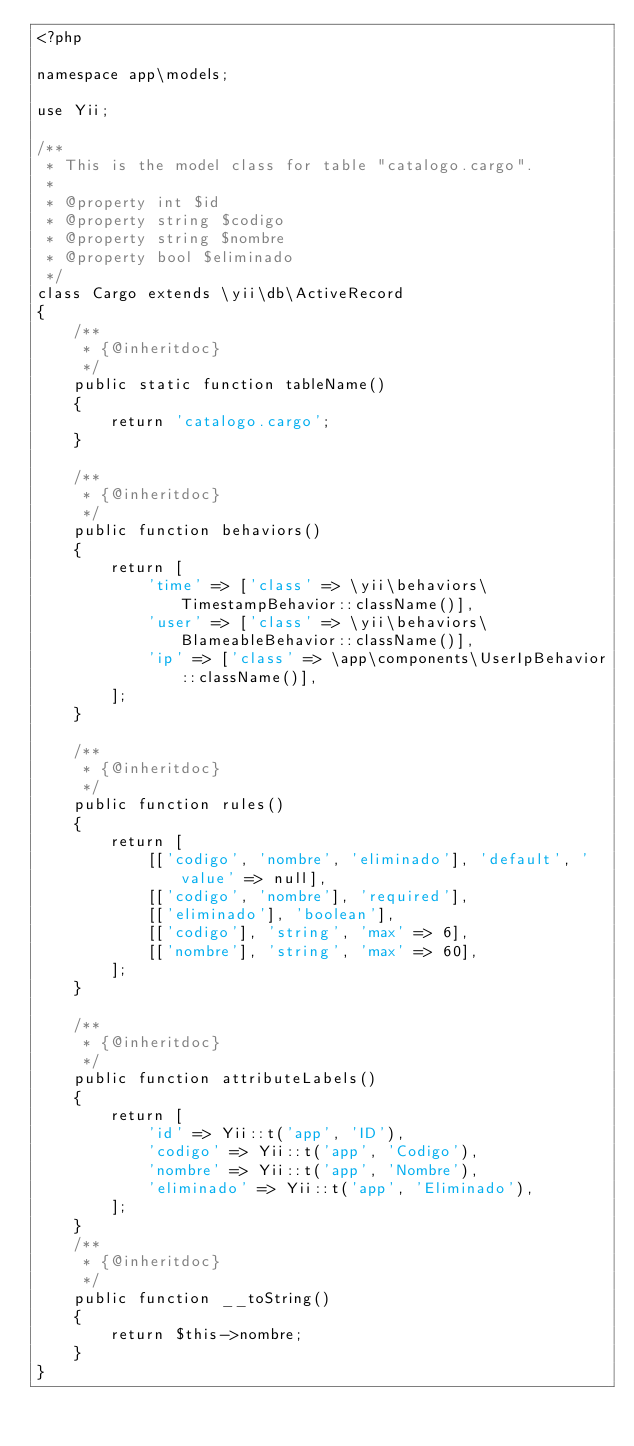Convert code to text. <code><loc_0><loc_0><loc_500><loc_500><_PHP_><?php

namespace app\models;

use Yii;

/**
 * This is the model class for table "catalogo.cargo".
 *
 * @property int $id
 * @property string $codigo
 * @property string $nombre
 * @property bool $eliminado
 */
class Cargo extends \yii\db\ActiveRecord
{
    /**
     * {@inheritdoc}
     */
    public static function tableName()
    {
        return 'catalogo.cargo';
    }

    /**
     * {@inheritdoc}
     */
    public function behaviors()
    {
        return [
            'time' => ['class' => \yii\behaviors\TimestampBehavior::className()],
            'user' => ['class' => \yii\behaviors\BlameableBehavior::className()],
            'ip' => ['class' => \app\components\UserIpBehavior::className()],
        ];
    }

    /**
     * {@inheritdoc}
     */
    public function rules()
    {
        return [
            [['codigo', 'nombre', 'eliminado'], 'default', 'value' => null],
            [['codigo', 'nombre'], 'required'],
            [['eliminado'], 'boolean'],
            [['codigo'], 'string', 'max' => 6],
            [['nombre'], 'string', 'max' => 60],
        ];
    }

    /**
     * {@inheritdoc}
     */
    public function attributeLabels()
    {
        return [
            'id' => Yii::t('app', 'ID'),
            'codigo' => Yii::t('app', 'Codigo'),
            'nombre' => Yii::t('app', 'Nombre'),
            'eliminado' => Yii::t('app', 'Eliminado'),
        ];
    }
    /**
     * {@inheritdoc}
     */
    public function __toString()
    {
        return $this->nombre;
    }
}
</code> 